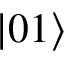Convert formula to latex. <formula><loc_0><loc_0><loc_500><loc_500>\left | 0 1 \right ></formula> 